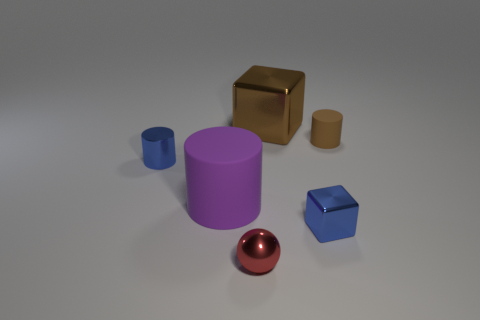How many things are on the left side of the red sphere and behind the tiny brown matte object?
Offer a very short reply. 0. There is a brown object that is made of the same material as the ball; what size is it?
Keep it short and to the point. Large. What number of tiny blue metal objects are the same shape as the large brown shiny thing?
Ensure brevity in your answer.  1. Is the number of blue cubes that are to the right of the metallic cylinder greater than the number of big red rubber blocks?
Keep it short and to the point. Yes. The tiny shiny thing that is behind the metal sphere and on the right side of the large purple thing has what shape?
Offer a very short reply. Cube. Do the brown rubber thing and the blue metallic cylinder have the same size?
Your answer should be compact. Yes. There is a tiny shiny sphere; what number of objects are behind it?
Make the answer very short. 5. Are there an equal number of small red metal spheres that are behind the brown metal object and large purple things right of the small brown cylinder?
Your answer should be compact. Yes. Does the red metal thing that is on the left side of the large brown thing have the same shape as the big brown shiny thing?
Provide a short and direct response. No. There is a purple cylinder; is it the same size as the blue thing on the left side of the red thing?
Your response must be concise. No. 